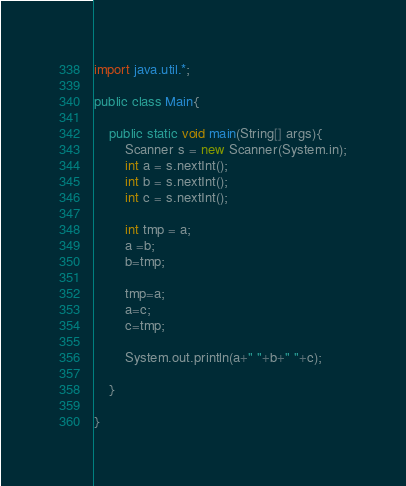<code> <loc_0><loc_0><loc_500><loc_500><_Java_>import java.util.*;

public class Main{

	public static void main(String[] args){
		Scanner s = new Scanner(System.in);
		int a = s.nextInt();
		int b = s.nextInt();
		int c = s.nextInt();
		
		int tmp = a;
		a =b;
		b=tmp;
		
		tmp=a;
		a=c;
		c=tmp;
		
		System.out.println(a+" "+b+" "+c);
		
	}

}</code> 